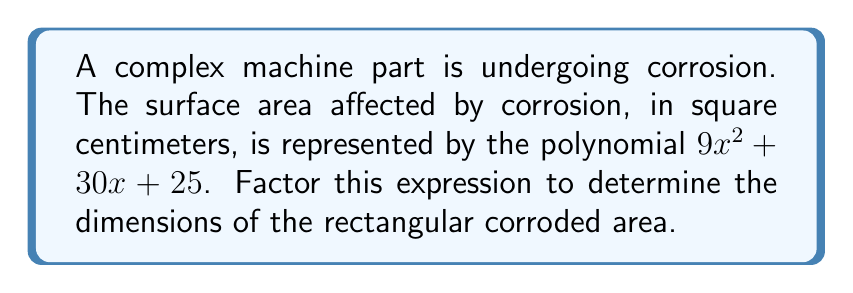Could you help me with this problem? To factor the polynomial $9x^2 + 30x + 25$, we'll use the following steps:

1) First, identify this as a quadratic expression in the form $ax^2 + bx + c$, where:
   $a = 9$, $b = 30$, and $c = 25$

2) We'll use the method of factoring by grouping. To do this, we need to find two numbers that multiply to give $ac$ and add up to $b$.

3) $ac = 9 \times 25 = 225$
   We need two numbers that multiply to give 225 and add up to 30.
   These numbers are 15 and 15.

4) Rewrite the middle term using these numbers:
   $9x^2 + 15x + 15x + 25$

5) Factor by grouping:
   $(9x^2 + 15x) + (15x + 25)$
   $3x(3x + 5) + 5(3x + 5)$

6) Factor out the common term $(3x + 5)$:
   $(3x + 5)(3x + 5)$

7) This can be written as a perfect square:
   $(3x + 5)^2$

Therefore, the factored expression is $(3x + 5)^2$, which represents a square with side length $(3x + 5)$ cm.
Answer: $(3x + 5)^2$ 